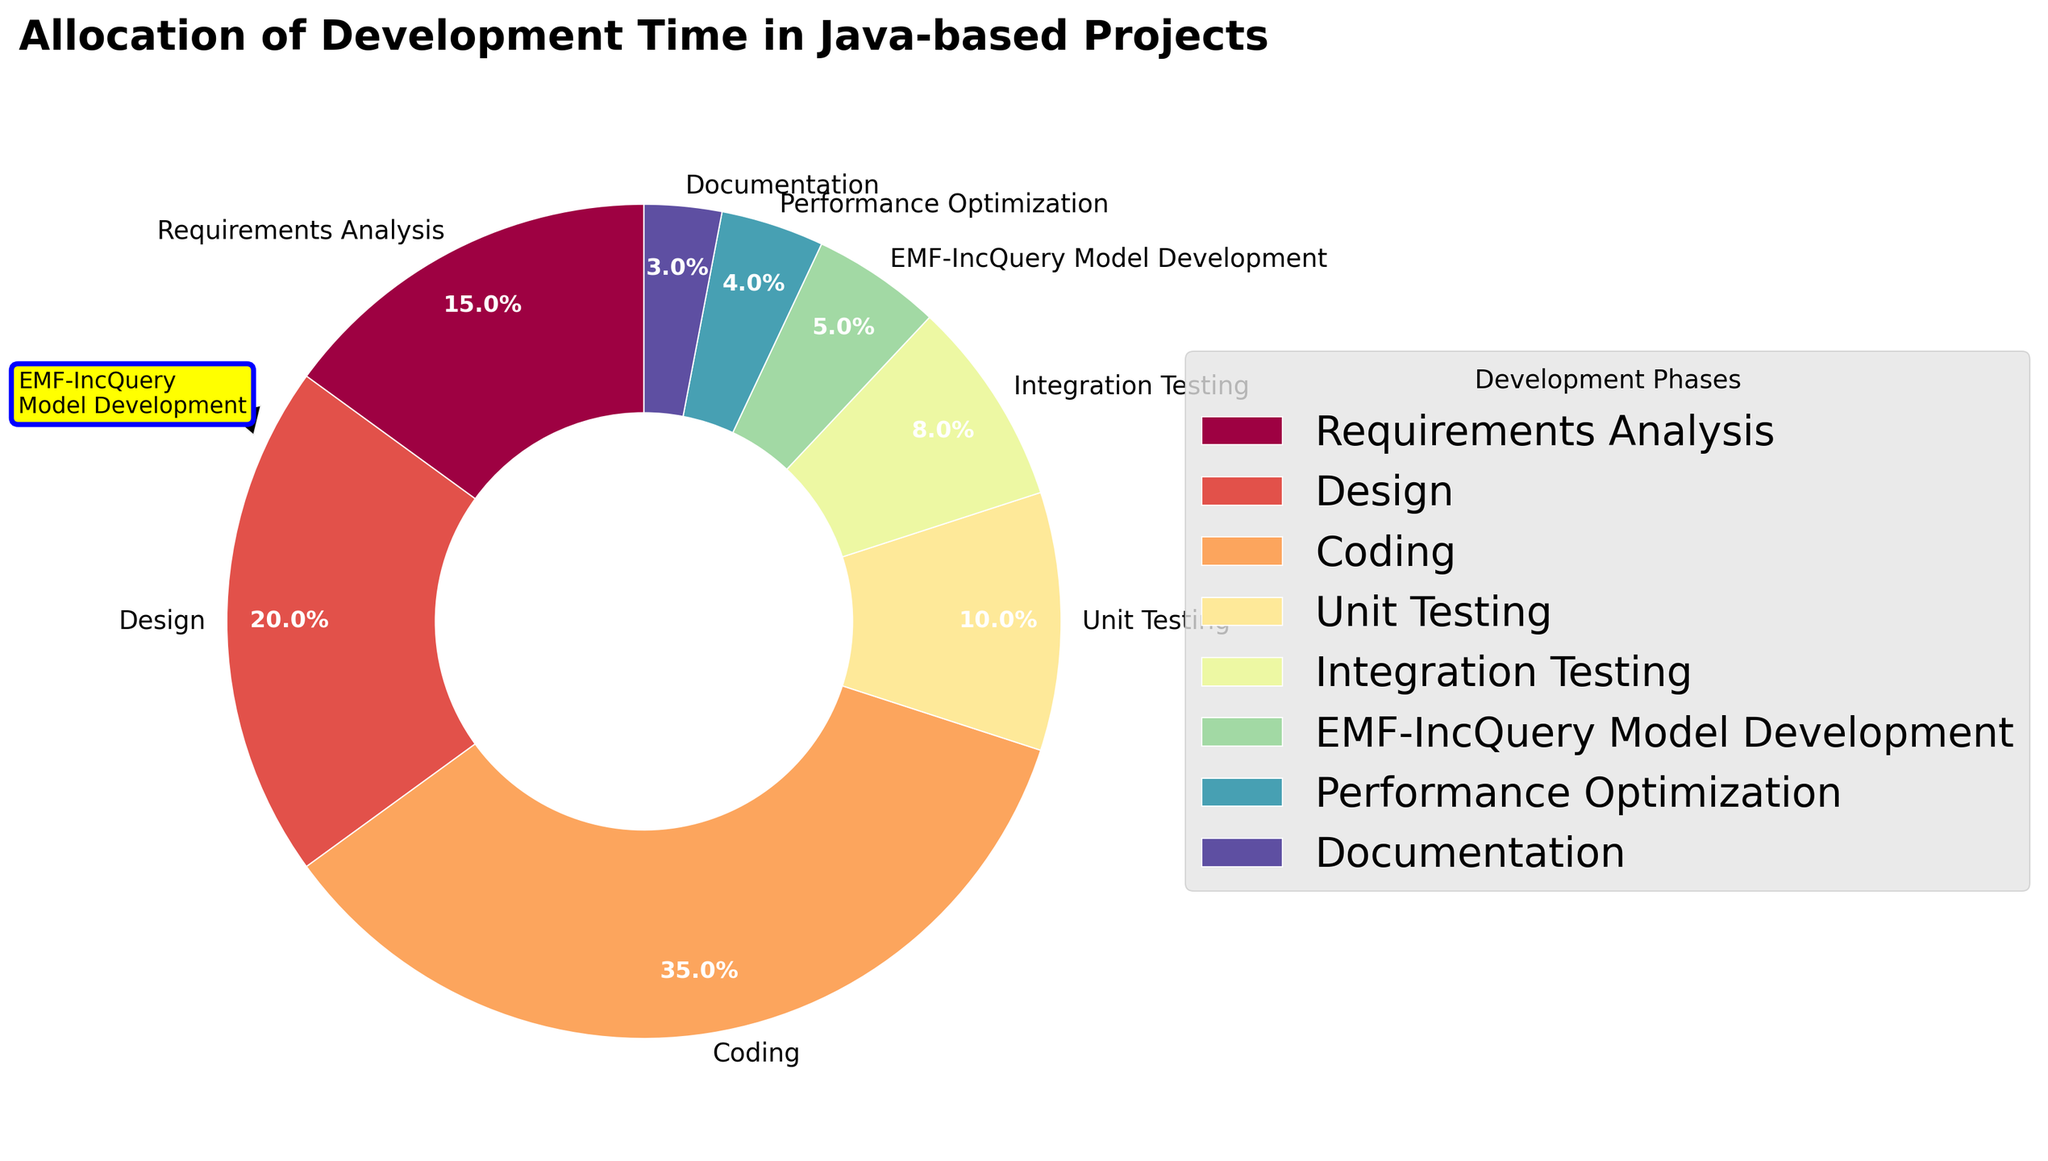What is the percentage allocation for Coding? Locate the section labeled "Coding" on the pie chart and read the percentage value associated with it.
Answer: 35% Which phase takes up the smallest portion of the development time? Identify the phase with the smallest wedge in the pie chart.
Answer: Documentation What is the combined percentage of Requirements Analysis and Integration Testing? Add the percentages of "Requirements Analysis" (15) and "Integration Testing" (8) together: 15 + 8 = 23.
Answer: 23% How does the percentage allocation for Unit Testing compare to that for EMF-IncQuery Model Development? Compare the percentages of "Unit Testing" (10) and "EMF-IncQuery Model Development" (5).
Answer: Unit Testing is greater What is the difference in percentage allocation between Design and Performance Optimization? Subtract the percentage of "Performance Optimization" (4) from "Design" (20): 20 - 4 = 16.
Answer: 16 If the phases Design and Coding are combined, what would be their total percentage allocation? Add the percentages of "Design" (20) and "Coding" (35) together: 20 + 35 = 55.
Answer: 55% Which phase is represented by the green color? Usually, the colors in the pie chart transition in a spectrum. Identify the phase whose wedge is greenish.
Answer: Unit Testing How much more time is allocated to Requirements Analysis than to Documentation? Subtract the percentage of "Documentation" (3) from "Requirements Analysis" (15): 15 - 3 = 12.
Answer: 12 Which two phases have the most similar percentage allocation, and what are their percentages? Compare the percentages and identify the two closest values. "Integration Testing" (8) and "EMF-IncQuery Model Development" (5) are fairly close but "Performance Optimization" (4) is closer to "EMF-IncQuery Model Development" (5).
Answer: EMF-IncQuery Model Development (5) and Performance Optimization (4) 